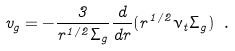<formula> <loc_0><loc_0><loc_500><loc_500>v _ { g } = - \frac { 3 } { r ^ { 1 / 2 } \Sigma _ { g } } \frac { d } { d r } ( r ^ { 1 / 2 } \nu _ { t } \Sigma _ { g } ) \ .</formula> 